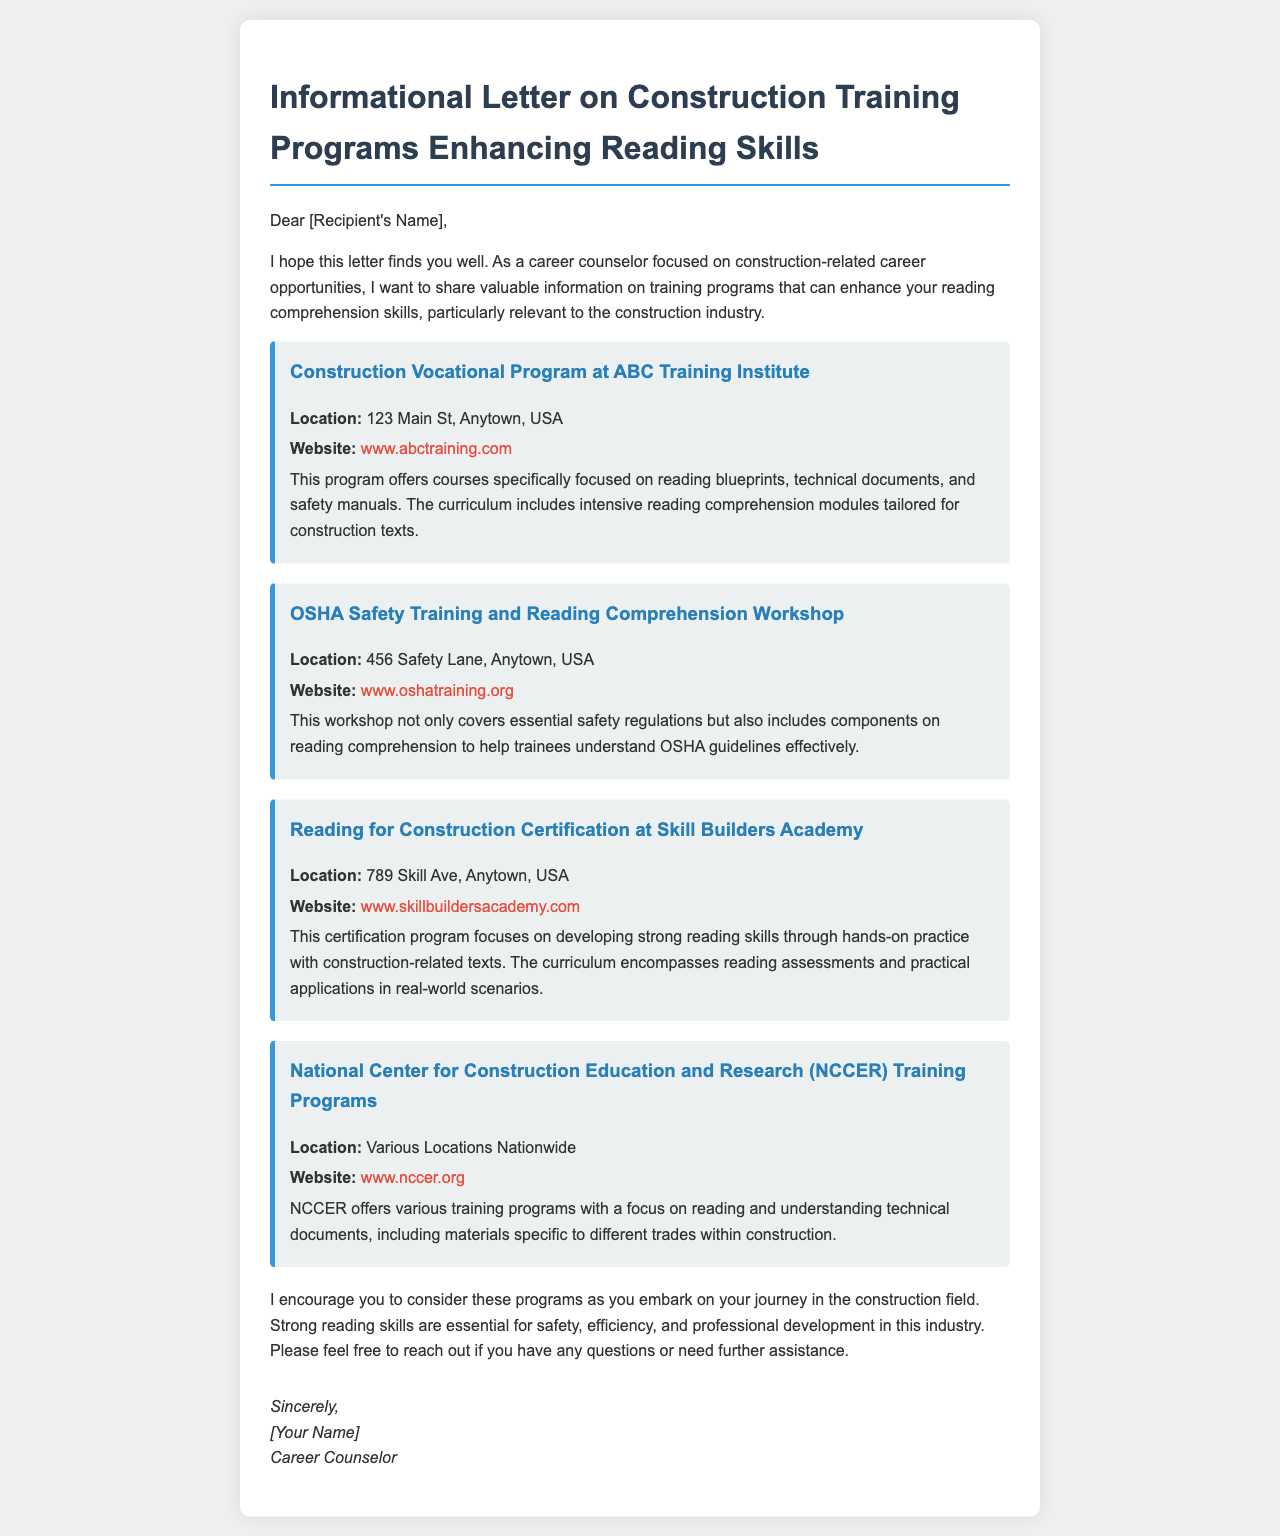What is the name of the first training program mentioned? The first program detailed in the document is called "Construction Vocational Program at ABC Training Institute."
Answer: Construction Vocational Program at ABC Training Institute Where is the OSHA Safety Training workshop located? The workshop's location is explicitly stated in the document as "456 Safety Lane, Anytown, USA."
Answer: 456 Safety Lane, Anytown, USA What is the primary focus of the Reading for Construction Certification? The certification program centers on developing strong reading skills through hands-on practice with construction-related texts.
Answer: Developing strong reading skills What is the website for the National Center for Construction Education and Research? The link provided in the document for NCCER is "www.nccer.org."
Answer: www.nccer.org What do all the training programs in the document seek to enhance? All training programs are designed to enhance reading comprehension skills specifically for the construction industry.
Answer: Reading comprehension skills What type of document is this? The document is an informational letter related to training programs in the construction field.
Answer: Informational letter Why is strong reading comprehension important in the construction industry? The letter highlights that strong reading skills are essential for safety, efficiency, and professional development in this industry.
Answer: Safety, efficiency, and professional development 